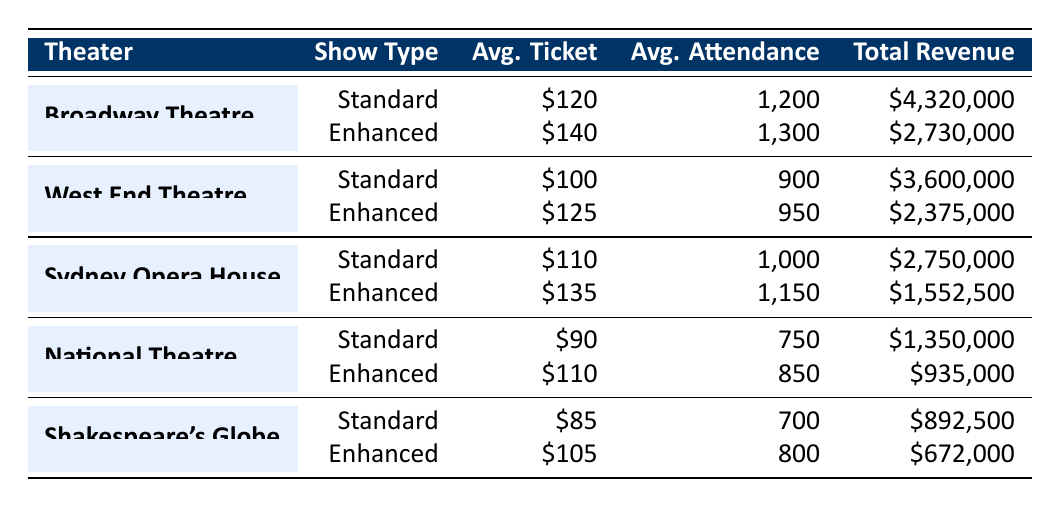What is the total revenue from standard shows at the Broadway Theatre? The total revenue from standard shows at the Broadway Theatre is listed as 4,320,000 in the table.
Answer: 4,320,000 How many sound-enhanced shows were performed at the West End Theatre? The number of sound-enhanced shows at the West End Theatre is 20, which is directly stated in the table.
Answer: 20 What is the average ticket price for sound-enhanced shows at the Sydney Opera House? The table states that the average ticket price for sound-enhanced shows at the Sydney Opera House is 135.
Answer: 135 Is the total revenue from standard shows higher at Shakespeare's Globe than at National Theatre? The total revenue from standard shows at Shakespeare's Globe is 892,500, and at National Theatre, it is 1,350,000. Therefore, Shakespeare's Globe has lower revenue.
Answer: No What is the percentage increase in average ticket price from standard shows to sound-enhanced shows for the Broadway Theatre? The average ticket price increases from 120 to 140, so the difference is 20. The percentage increase is calculated as (20/120) * 100 = 16.67%.
Answer: 16.67% Which theater had the highest average attendance for sound-enhanced shows? For sound-enhanced shows, the average attendance at the Broadway Theatre is 1,300, at the West End Theatre is 950, at Sydney Opera House is 1,150, at National Theatre is 850, and at Shakespeare's Globe is 800. The Broadway Theatre has the highest average attendance.
Answer: Broadway Theatre What is the difference in total revenue between standard and sound-enhanced shows at the National Theatre? The total revenue from standard shows at National Theatre is 1,350,000 and from sound-enhanced shows is 935,000. The difference is 1,350,000 - 935,000 = 415,000.
Answer: 415,000 Did sound-enhanced shows generate more total revenue than standard shows in any theater? Reviewing the total revenues: the highest from standard shows is 4,320,000 at Broadway Theatre and the highest from sound-enhanced shows is 2,730,000. Standard shows consistently generate more revenue.
Answer: No What is the average attendance across all standard shows? To find this, sum the average attendances (1200 + 900 + 1000 + 750 + 700 = 3550) and divide by the number of theaters (5). The average is 3550 / 5 = 710.
Answer: 710 